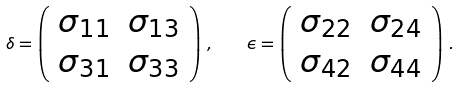Convert formula to latex. <formula><loc_0><loc_0><loc_500><loc_500>\delta = \left ( \begin{array} { c c } \sigma _ { 1 1 } & \sigma _ { 1 3 } \\ \sigma _ { 3 1 } & \sigma _ { 3 3 } \end{array} \right ) \, , \quad \epsilon = \left ( \begin{array} { c c } \sigma _ { 2 2 } & \sigma _ { 2 4 } \\ \sigma _ { 4 2 } & \sigma _ { 4 4 } \end{array} \right ) \, .</formula> 